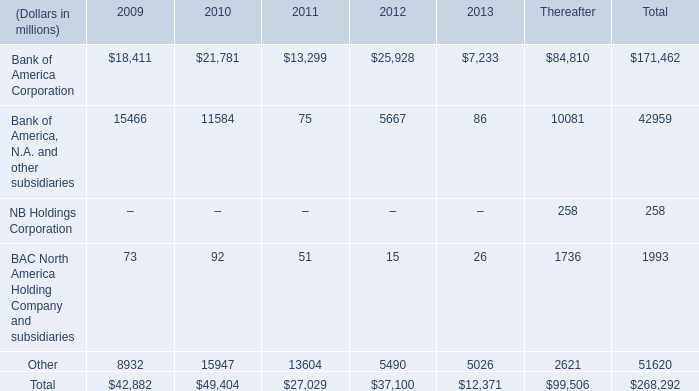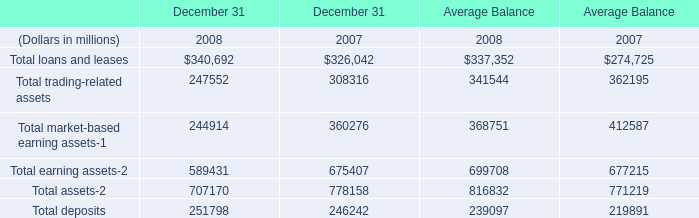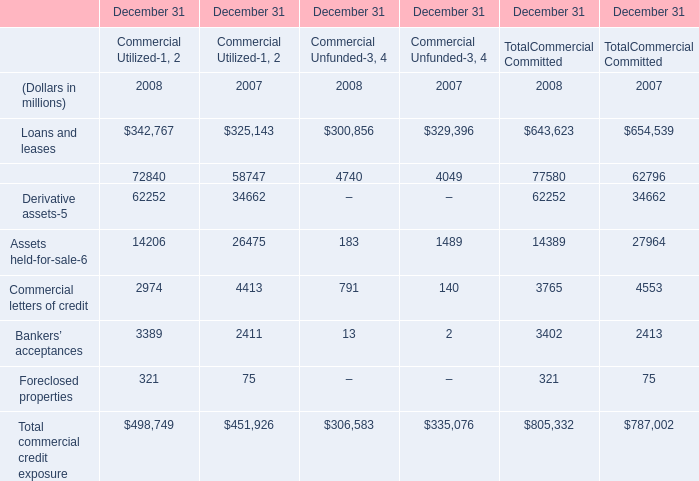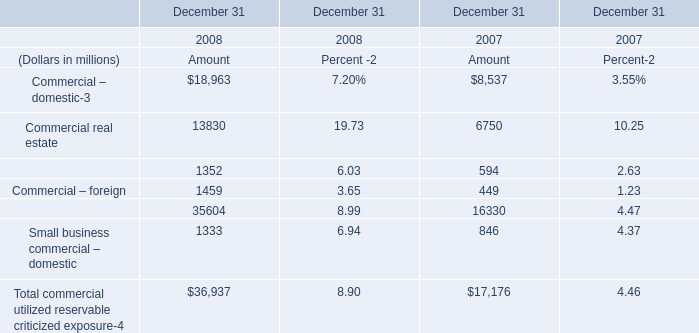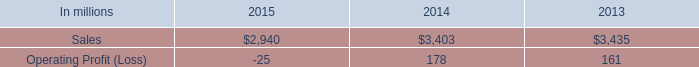What's the total amount of the Loans and leases of commercial utilized in the years where Assets held-for-sale of commercial utilized is greater than 15000? (in millions) 
Answer: 325143. 